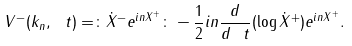<formula> <loc_0><loc_0><loc_500><loc_500>V ^ { - } ( k _ { n } , \ t ) = \colon \dot { X } ^ { - } e ^ { i n X ^ { + } } \colon - \frac { 1 } { 2 } i n \frac { d } { d \ t } ( \log \dot { X } ^ { + } ) e ^ { i n X ^ { + } } .</formula> 